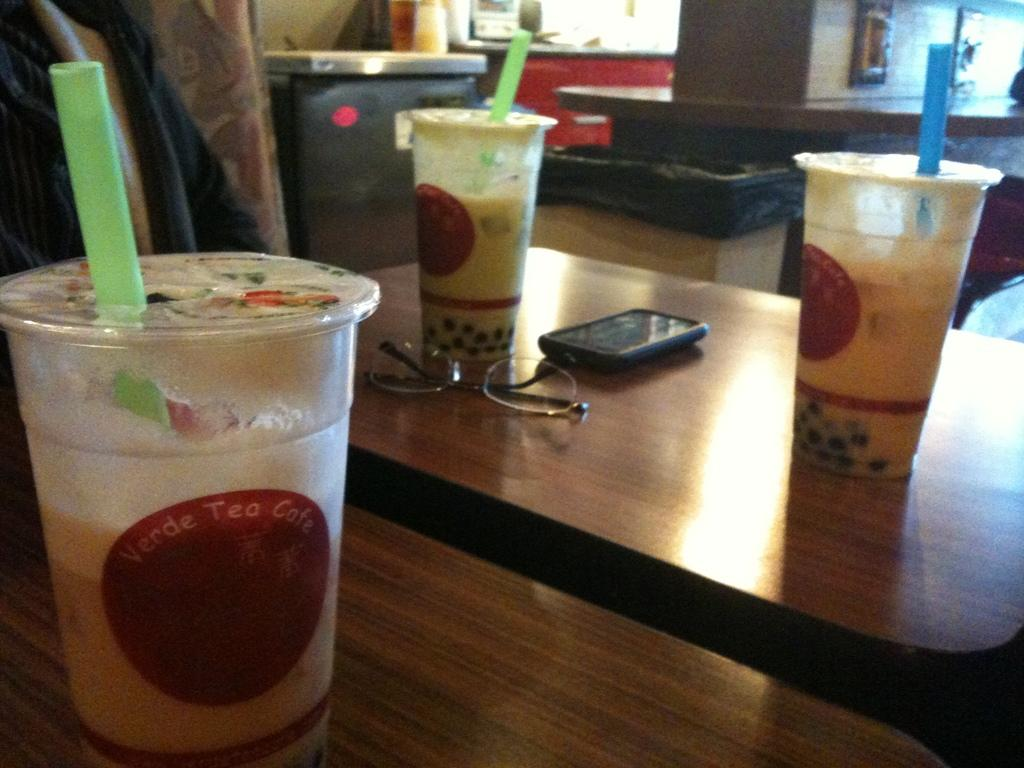Provide a one-sentence caption for the provided image. 3 Cups of tea from the Verde Tea Cafe sit on wooden tables. 